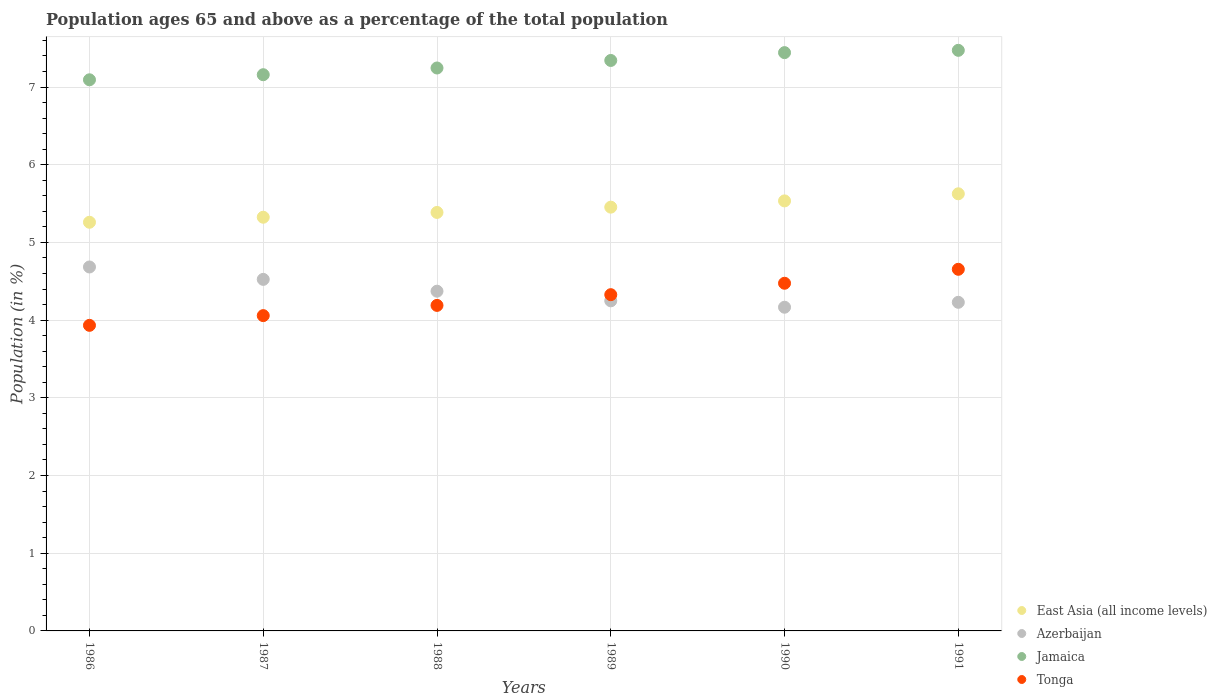Is the number of dotlines equal to the number of legend labels?
Provide a succinct answer. Yes. What is the percentage of the population ages 65 and above in Tonga in 1988?
Your response must be concise. 4.19. Across all years, what is the maximum percentage of the population ages 65 and above in Jamaica?
Your response must be concise. 7.47. Across all years, what is the minimum percentage of the population ages 65 and above in Azerbaijan?
Ensure brevity in your answer.  4.17. In which year was the percentage of the population ages 65 and above in Jamaica maximum?
Your answer should be compact. 1991. What is the total percentage of the population ages 65 and above in Tonga in the graph?
Make the answer very short. 25.64. What is the difference between the percentage of the population ages 65 and above in Azerbaijan in 1988 and that in 1989?
Provide a succinct answer. 0.12. What is the difference between the percentage of the population ages 65 and above in East Asia (all income levels) in 1991 and the percentage of the population ages 65 and above in Tonga in 1989?
Offer a terse response. 1.3. What is the average percentage of the population ages 65 and above in Tonga per year?
Your response must be concise. 4.27. In the year 1991, what is the difference between the percentage of the population ages 65 and above in Jamaica and percentage of the population ages 65 and above in East Asia (all income levels)?
Keep it short and to the point. 1.85. In how many years, is the percentage of the population ages 65 and above in Jamaica greater than 6.8?
Provide a succinct answer. 6. What is the ratio of the percentage of the population ages 65 and above in Jamaica in 1989 to that in 1990?
Offer a very short reply. 0.99. What is the difference between the highest and the second highest percentage of the population ages 65 and above in East Asia (all income levels)?
Make the answer very short. 0.09. What is the difference between the highest and the lowest percentage of the population ages 65 and above in Jamaica?
Your answer should be compact. 0.38. Is it the case that in every year, the sum of the percentage of the population ages 65 and above in Jamaica and percentage of the population ages 65 and above in East Asia (all income levels)  is greater than the sum of percentage of the population ages 65 and above in Azerbaijan and percentage of the population ages 65 and above in Tonga?
Your response must be concise. Yes. Does the percentage of the population ages 65 and above in East Asia (all income levels) monotonically increase over the years?
Give a very brief answer. Yes. How many legend labels are there?
Keep it short and to the point. 4. What is the title of the graph?
Provide a succinct answer. Population ages 65 and above as a percentage of the total population. Does "Rwanda" appear as one of the legend labels in the graph?
Ensure brevity in your answer.  No. What is the Population (in %) of East Asia (all income levels) in 1986?
Keep it short and to the point. 5.26. What is the Population (in %) of Azerbaijan in 1986?
Your answer should be compact. 4.68. What is the Population (in %) in Jamaica in 1986?
Make the answer very short. 7.09. What is the Population (in %) of Tonga in 1986?
Ensure brevity in your answer.  3.93. What is the Population (in %) in East Asia (all income levels) in 1987?
Make the answer very short. 5.32. What is the Population (in %) in Azerbaijan in 1987?
Ensure brevity in your answer.  4.52. What is the Population (in %) of Jamaica in 1987?
Offer a very short reply. 7.16. What is the Population (in %) of Tonga in 1987?
Provide a succinct answer. 4.06. What is the Population (in %) of East Asia (all income levels) in 1988?
Your response must be concise. 5.39. What is the Population (in %) in Azerbaijan in 1988?
Your answer should be compact. 4.37. What is the Population (in %) of Jamaica in 1988?
Provide a short and direct response. 7.25. What is the Population (in %) in Tonga in 1988?
Offer a terse response. 4.19. What is the Population (in %) of East Asia (all income levels) in 1989?
Your response must be concise. 5.45. What is the Population (in %) in Azerbaijan in 1989?
Your response must be concise. 4.25. What is the Population (in %) of Jamaica in 1989?
Your answer should be very brief. 7.34. What is the Population (in %) of Tonga in 1989?
Provide a short and direct response. 4.33. What is the Population (in %) of East Asia (all income levels) in 1990?
Offer a very short reply. 5.53. What is the Population (in %) of Azerbaijan in 1990?
Offer a very short reply. 4.17. What is the Population (in %) in Jamaica in 1990?
Your answer should be very brief. 7.44. What is the Population (in %) of Tonga in 1990?
Your answer should be very brief. 4.47. What is the Population (in %) in East Asia (all income levels) in 1991?
Provide a succinct answer. 5.63. What is the Population (in %) in Azerbaijan in 1991?
Provide a short and direct response. 4.23. What is the Population (in %) in Jamaica in 1991?
Ensure brevity in your answer.  7.47. What is the Population (in %) in Tonga in 1991?
Your answer should be very brief. 4.65. Across all years, what is the maximum Population (in %) of East Asia (all income levels)?
Ensure brevity in your answer.  5.63. Across all years, what is the maximum Population (in %) of Azerbaijan?
Keep it short and to the point. 4.68. Across all years, what is the maximum Population (in %) of Jamaica?
Provide a short and direct response. 7.47. Across all years, what is the maximum Population (in %) of Tonga?
Keep it short and to the point. 4.65. Across all years, what is the minimum Population (in %) in East Asia (all income levels)?
Your response must be concise. 5.26. Across all years, what is the minimum Population (in %) in Azerbaijan?
Provide a succinct answer. 4.17. Across all years, what is the minimum Population (in %) of Jamaica?
Provide a succinct answer. 7.09. Across all years, what is the minimum Population (in %) of Tonga?
Provide a succinct answer. 3.93. What is the total Population (in %) of East Asia (all income levels) in the graph?
Your response must be concise. 32.59. What is the total Population (in %) in Azerbaijan in the graph?
Offer a very short reply. 26.23. What is the total Population (in %) in Jamaica in the graph?
Your answer should be very brief. 43.76. What is the total Population (in %) of Tonga in the graph?
Provide a succinct answer. 25.64. What is the difference between the Population (in %) of East Asia (all income levels) in 1986 and that in 1987?
Keep it short and to the point. -0.06. What is the difference between the Population (in %) of Azerbaijan in 1986 and that in 1987?
Provide a short and direct response. 0.16. What is the difference between the Population (in %) of Jamaica in 1986 and that in 1987?
Provide a succinct answer. -0.07. What is the difference between the Population (in %) of Tonga in 1986 and that in 1987?
Provide a short and direct response. -0.13. What is the difference between the Population (in %) in East Asia (all income levels) in 1986 and that in 1988?
Offer a very short reply. -0.13. What is the difference between the Population (in %) of Azerbaijan in 1986 and that in 1988?
Ensure brevity in your answer.  0.31. What is the difference between the Population (in %) of Jamaica in 1986 and that in 1988?
Provide a short and direct response. -0.15. What is the difference between the Population (in %) in Tonga in 1986 and that in 1988?
Your response must be concise. -0.26. What is the difference between the Population (in %) in East Asia (all income levels) in 1986 and that in 1989?
Offer a terse response. -0.19. What is the difference between the Population (in %) of Azerbaijan in 1986 and that in 1989?
Give a very brief answer. 0.44. What is the difference between the Population (in %) of Jamaica in 1986 and that in 1989?
Provide a short and direct response. -0.25. What is the difference between the Population (in %) of Tonga in 1986 and that in 1989?
Your response must be concise. -0.39. What is the difference between the Population (in %) of East Asia (all income levels) in 1986 and that in 1990?
Make the answer very short. -0.27. What is the difference between the Population (in %) of Azerbaijan in 1986 and that in 1990?
Keep it short and to the point. 0.52. What is the difference between the Population (in %) of Jamaica in 1986 and that in 1990?
Provide a short and direct response. -0.35. What is the difference between the Population (in %) in Tonga in 1986 and that in 1990?
Your answer should be very brief. -0.54. What is the difference between the Population (in %) of East Asia (all income levels) in 1986 and that in 1991?
Your answer should be very brief. -0.37. What is the difference between the Population (in %) of Azerbaijan in 1986 and that in 1991?
Keep it short and to the point. 0.45. What is the difference between the Population (in %) in Jamaica in 1986 and that in 1991?
Ensure brevity in your answer.  -0.38. What is the difference between the Population (in %) of Tonga in 1986 and that in 1991?
Provide a succinct answer. -0.72. What is the difference between the Population (in %) in East Asia (all income levels) in 1987 and that in 1988?
Ensure brevity in your answer.  -0.06. What is the difference between the Population (in %) in Azerbaijan in 1987 and that in 1988?
Your answer should be compact. 0.15. What is the difference between the Population (in %) of Jamaica in 1987 and that in 1988?
Provide a succinct answer. -0.09. What is the difference between the Population (in %) of Tonga in 1987 and that in 1988?
Make the answer very short. -0.13. What is the difference between the Population (in %) of East Asia (all income levels) in 1987 and that in 1989?
Give a very brief answer. -0.13. What is the difference between the Population (in %) in Azerbaijan in 1987 and that in 1989?
Your response must be concise. 0.28. What is the difference between the Population (in %) in Jamaica in 1987 and that in 1989?
Provide a succinct answer. -0.18. What is the difference between the Population (in %) of Tonga in 1987 and that in 1989?
Make the answer very short. -0.27. What is the difference between the Population (in %) of East Asia (all income levels) in 1987 and that in 1990?
Your answer should be compact. -0.21. What is the difference between the Population (in %) of Azerbaijan in 1987 and that in 1990?
Your answer should be very brief. 0.36. What is the difference between the Population (in %) in Jamaica in 1987 and that in 1990?
Make the answer very short. -0.28. What is the difference between the Population (in %) in Tonga in 1987 and that in 1990?
Offer a terse response. -0.42. What is the difference between the Population (in %) of East Asia (all income levels) in 1987 and that in 1991?
Offer a very short reply. -0.3. What is the difference between the Population (in %) in Azerbaijan in 1987 and that in 1991?
Offer a very short reply. 0.3. What is the difference between the Population (in %) of Jamaica in 1987 and that in 1991?
Your answer should be very brief. -0.31. What is the difference between the Population (in %) in Tonga in 1987 and that in 1991?
Give a very brief answer. -0.6. What is the difference between the Population (in %) in East Asia (all income levels) in 1988 and that in 1989?
Provide a short and direct response. -0.07. What is the difference between the Population (in %) of Azerbaijan in 1988 and that in 1989?
Make the answer very short. 0.12. What is the difference between the Population (in %) in Jamaica in 1988 and that in 1989?
Your answer should be compact. -0.1. What is the difference between the Population (in %) of Tonga in 1988 and that in 1989?
Your answer should be very brief. -0.14. What is the difference between the Population (in %) in East Asia (all income levels) in 1988 and that in 1990?
Offer a terse response. -0.15. What is the difference between the Population (in %) in Azerbaijan in 1988 and that in 1990?
Your answer should be compact. 0.21. What is the difference between the Population (in %) of Jamaica in 1988 and that in 1990?
Your answer should be very brief. -0.2. What is the difference between the Population (in %) of Tonga in 1988 and that in 1990?
Give a very brief answer. -0.28. What is the difference between the Population (in %) in East Asia (all income levels) in 1988 and that in 1991?
Give a very brief answer. -0.24. What is the difference between the Population (in %) in Azerbaijan in 1988 and that in 1991?
Provide a short and direct response. 0.14. What is the difference between the Population (in %) in Jamaica in 1988 and that in 1991?
Ensure brevity in your answer.  -0.23. What is the difference between the Population (in %) of Tonga in 1988 and that in 1991?
Give a very brief answer. -0.46. What is the difference between the Population (in %) of East Asia (all income levels) in 1989 and that in 1990?
Your answer should be compact. -0.08. What is the difference between the Population (in %) in Azerbaijan in 1989 and that in 1990?
Ensure brevity in your answer.  0.08. What is the difference between the Population (in %) in Jamaica in 1989 and that in 1990?
Your response must be concise. -0.1. What is the difference between the Population (in %) of Tonga in 1989 and that in 1990?
Provide a short and direct response. -0.15. What is the difference between the Population (in %) of East Asia (all income levels) in 1989 and that in 1991?
Ensure brevity in your answer.  -0.17. What is the difference between the Population (in %) in Azerbaijan in 1989 and that in 1991?
Give a very brief answer. 0.02. What is the difference between the Population (in %) of Jamaica in 1989 and that in 1991?
Offer a terse response. -0.13. What is the difference between the Population (in %) of Tonga in 1989 and that in 1991?
Ensure brevity in your answer.  -0.33. What is the difference between the Population (in %) of East Asia (all income levels) in 1990 and that in 1991?
Ensure brevity in your answer.  -0.09. What is the difference between the Population (in %) of Azerbaijan in 1990 and that in 1991?
Make the answer very short. -0.06. What is the difference between the Population (in %) in Jamaica in 1990 and that in 1991?
Make the answer very short. -0.03. What is the difference between the Population (in %) of Tonga in 1990 and that in 1991?
Your answer should be compact. -0.18. What is the difference between the Population (in %) in East Asia (all income levels) in 1986 and the Population (in %) in Azerbaijan in 1987?
Your answer should be very brief. 0.74. What is the difference between the Population (in %) of East Asia (all income levels) in 1986 and the Population (in %) of Jamaica in 1987?
Give a very brief answer. -1.9. What is the difference between the Population (in %) in East Asia (all income levels) in 1986 and the Population (in %) in Tonga in 1987?
Keep it short and to the point. 1.2. What is the difference between the Population (in %) of Azerbaijan in 1986 and the Population (in %) of Jamaica in 1987?
Offer a very short reply. -2.47. What is the difference between the Population (in %) of Azerbaijan in 1986 and the Population (in %) of Tonga in 1987?
Keep it short and to the point. 0.63. What is the difference between the Population (in %) in Jamaica in 1986 and the Population (in %) in Tonga in 1987?
Make the answer very short. 3.04. What is the difference between the Population (in %) in East Asia (all income levels) in 1986 and the Population (in %) in Azerbaijan in 1988?
Your response must be concise. 0.89. What is the difference between the Population (in %) of East Asia (all income levels) in 1986 and the Population (in %) of Jamaica in 1988?
Provide a short and direct response. -1.99. What is the difference between the Population (in %) in East Asia (all income levels) in 1986 and the Population (in %) in Tonga in 1988?
Your answer should be compact. 1.07. What is the difference between the Population (in %) of Azerbaijan in 1986 and the Population (in %) of Jamaica in 1988?
Your response must be concise. -2.56. What is the difference between the Population (in %) in Azerbaijan in 1986 and the Population (in %) in Tonga in 1988?
Offer a very short reply. 0.49. What is the difference between the Population (in %) in Jamaica in 1986 and the Population (in %) in Tonga in 1988?
Provide a short and direct response. 2.9. What is the difference between the Population (in %) in East Asia (all income levels) in 1986 and the Population (in %) in Azerbaijan in 1989?
Provide a short and direct response. 1.01. What is the difference between the Population (in %) of East Asia (all income levels) in 1986 and the Population (in %) of Jamaica in 1989?
Keep it short and to the point. -2.08. What is the difference between the Population (in %) in East Asia (all income levels) in 1986 and the Population (in %) in Tonga in 1989?
Offer a very short reply. 0.93. What is the difference between the Population (in %) in Azerbaijan in 1986 and the Population (in %) in Jamaica in 1989?
Give a very brief answer. -2.66. What is the difference between the Population (in %) of Azerbaijan in 1986 and the Population (in %) of Tonga in 1989?
Your answer should be compact. 0.36. What is the difference between the Population (in %) of Jamaica in 1986 and the Population (in %) of Tonga in 1989?
Give a very brief answer. 2.77. What is the difference between the Population (in %) in East Asia (all income levels) in 1986 and the Population (in %) in Azerbaijan in 1990?
Your answer should be compact. 1.09. What is the difference between the Population (in %) in East Asia (all income levels) in 1986 and the Population (in %) in Jamaica in 1990?
Provide a succinct answer. -2.18. What is the difference between the Population (in %) of East Asia (all income levels) in 1986 and the Population (in %) of Tonga in 1990?
Ensure brevity in your answer.  0.79. What is the difference between the Population (in %) in Azerbaijan in 1986 and the Population (in %) in Jamaica in 1990?
Your response must be concise. -2.76. What is the difference between the Population (in %) of Azerbaijan in 1986 and the Population (in %) of Tonga in 1990?
Your answer should be compact. 0.21. What is the difference between the Population (in %) of Jamaica in 1986 and the Population (in %) of Tonga in 1990?
Offer a terse response. 2.62. What is the difference between the Population (in %) of East Asia (all income levels) in 1986 and the Population (in %) of Azerbaijan in 1991?
Make the answer very short. 1.03. What is the difference between the Population (in %) of East Asia (all income levels) in 1986 and the Population (in %) of Jamaica in 1991?
Provide a succinct answer. -2.21. What is the difference between the Population (in %) of East Asia (all income levels) in 1986 and the Population (in %) of Tonga in 1991?
Give a very brief answer. 0.61. What is the difference between the Population (in %) of Azerbaijan in 1986 and the Population (in %) of Jamaica in 1991?
Your response must be concise. -2.79. What is the difference between the Population (in %) of Azerbaijan in 1986 and the Population (in %) of Tonga in 1991?
Provide a short and direct response. 0.03. What is the difference between the Population (in %) in Jamaica in 1986 and the Population (in %) in Tonga in 1991?
Your answer should be very brief. 2.44. What is the difference between the Population (in %) in East Asia (all income levels) in 1987 and the Population (in %) in Azerbaijan in 1988?
Your answer should be very brief. 0.95. What is the difference between the Population (in %) of East Asia (all income levels) in 1987 and the Population (in %) of Jamaica in 1988?
Make the answer very short. -1.92. What is the difference between the Population (in %) of East Asia (all income levels) in 1987 and the Population (in %) of Tonga in 1988?
Your answer should be very brief. 1.13. What is the difference between the Population (in %) of Azerbaijan in 1987 and the Population (in %) of Jamaica in 1988?
Offer a terse response. -2.72. What is the difference between the Population (in %) in Azerbaijan in 1987 and the Population (in %) in Tonga in 1988?
Provide a succinct answer. 0.33. What is the difference between the Population (in %) of Jamaica in 1987 and the Population (in %) of Tonga in 1988?
Your answer should be very brief. 2.97. What is the difference between the Population (in %) in East Asia (all income levels) in 1987 and the Population (in %) in Azerbaijan in 1989?
Your answer should be very brief. 1.08. What is the difference between the Population (in %) of East Asia (all income levels) in 1987 and the Population (in %) of Jamaica in 1989?
Your answer should be very brief. -2.02. What is the difference between the Population (in %) in East Asia (all income levels) in 1987 and the Population (in %) in Tonga in 1989?
Give a very brief answer. 1. What is the difference between the Population (in %) in Azerbaijan in 1987 and the Population (in %) in Jamaica in 1989?
Your response must be concise. -2.82. What is the difference between the Population (in %) in Azerbaijan in 1987 and the Population (in %) in Tonga in 1989?
Provide a succinct answer. 0.2. What is the difference between the Population (in %) of Jamaica in 1987 and the Population (in %) of Tonga in 1989?
Keep it short and to the point. 2.83. What is the difference between the Population (in %) in East Asia (all income levels) in 1987 and the Population (in %) in Azerbaijan in 1990?
Keep it short and to the point. 1.16. What is the difference between the Population (in %) of East Asia (all income levels) in 1987 and the Population (in %) of Jamaica in 1990?
Your answer should be very brief. -2.12. What is the difference between the Population (in %) in East Asia (all income levels) in 1987 and the Population (in %) in Tonga in 1990?
Your response must be concise. 0.85. What is the difference between the Population (in %) in Azerbaijan in 1987 and the Population (in %) in Jamaica in 1990?
Offer a very short reply. -2.92. What is the difference between the Population (in %) in Azerbaijan in 1987 and the Population (in %) in Tonga in 1990?
Your answer should be compact. 0.05. What is the difference between the Population (in %) in Jamaica in 1987 and the Population (in %) in Tonga in 1990?
Offer a terse response. 2.68. What is the difference between the Population (in %) of East Asia (all income levels) in 1987 and the Population (in %) of Azerbaijan in 1991?
Provide a succinct answer. 1.1. What is the difference between the Population (in %) in East Asia (all income levels) in 1987 and the Population (in %) in Jamaica in 1991?
Your answer should be very brief. -2.15. What is the difference between the Population (in %) of East Asia (all income levels) in 1987 and the Population (in %) of Tonga in 1991?
Your answer should be compact. 0.67. What is the difference between the Population (in %) of Azerbaijan in 1987 and the Population (in %) of Jamaica in 1991?
Your answer should be very brief. -2.95. What is the difference between the Population (in %) of Azerbaijan in 1987 and the Population (in %) of Tonga in 1991?
Provide a short and direct response. -0.13. What is the difference between the Population (in %) of Jamaica in 1987 and the Population (in %) of Tonga in 1991?
Offer a terse response. 2.5. What is the difference between the Population (in %) in East Asia (all income levels) in 1988 and the Population (in %) in Azerbaijan in 1989?
Keep it short and to the point. 1.14. What is the difference between the Population (in %) of East Asia (all income levels) in 1988 and the Population (in %) of Jamaica in 1989?
Offer a terse response. -1.96. What is the difference between the Population (in %) in East Asia (all income levels) in 1988 and the Population (in %) in Tonga in 1989?
Make the answer very short. 1.06. What is the difference between the Population (in %) of Azerbaijan in 1988 and the Population (in %) of Jamaica in 1989?
Make the answer very short. -2.97. What is the difference between the Population (in %) of Azerbaijan in 1988 and the Population (in %) of Tonga in 1989?
Keep it short and to the point. 0.04. What is the difference between the Population (in %) of Jamaica in 1988 and the Population (in %) of Tonga in 1989?
Give a very brief answer. 2.92. What is the difference between the Population (in %) in East Asia (all income levels) in 1988 and the Population (in %) in Azerbaijan in 1990?
Provide a short and direct response. 1.22. What is the difference between the Population (in %) in East Asia (all income levels) in 1988 and the Population (in %) in Jamaica in 1990?
Give a very brief answer. -2.06. What is the difference between the Population (in %) in East Asia (all income levels) in 1988 and the Population (in %) in Tonga in 1990?
Your answer should be very brief. 0.91. What is the difference between the Population (in %) of Azerbaijan in 1988 and the Population (in %) of Jamaica in 1990?
Ensure brevity in your answer.  -3.07. What is the difference between the Population (in %) in Azerbaijan in 1988 and the Population (in %) in Tonga in 1990?
Provide a succinct answer. -0.1. What is the difference between the Population (in %) in Jamaica in 1988 and the Population (in %) in Tonga in 1990?
Your answer should be compact. 2.77. What is the difference between the Population (in %) in East Asia (all income levels) in 1988 and the Population (in %) in Azerbaijan in 1991?
Your answer should be very brief. 1.16. What is the difference between the Population (in %) in East Asia (all income levels) in 1988 and the Population (in %) in Jamaica in 1991?
Offer a terse response. -2.09. What is the difference between the Population (in %) of East Asia (all income levels) in 1988 and the Population (in %) of Tonga in 1991?
Offer a very short reply. 0.73. What is the difference between the Population (in %) of Azerbaijan in 1988 and the Population (in %) of Jamaica in 1991?
Give a very brief answer. -3.1. What is the difference between the Population (in %) of Azerbaijan in 1988 and the Population (in %) of Tonga in 1991?
Provide a succinct answer. -0.28. What is the difference between the Population (in %) in Jamaica in 1988 and the Population (in %) in Tonga in 1991?
Make the answer very short. 2.59. What is the difference between the Population (in %) of East Asia (all income levels) in 1989 and the Population (in %) of Azerbaijan in 1990?
Give a very brief answer. 1.29. What is the difference between the Population (in %) of East Asia (all income levels) in 1989 and the Population (in %) of Jamaica in 1990?
Provide a short and direct response. -1.99. What is the difference between the Population (in %) in East Asia (all income levels) in 1989 and the Population (in %) in Tonga in 1990?
Your answer should be very brief. 0.98. What is the difference between the Population (in %) in Azerbaijan in 1989 and the Population (in %) in Jamaica in 1990?
Your answer should be very brief. -3.19. What is the difference between the Population (in %) of Azerbaijan in 1989 and the Population (in %) of Tonga in 1990?
Your response must be concise. -0.23. What is the difference between the Population (in %) in Jamaica in 1989 and the Population (in %) in Tonga in 1990?
Your answer should be compact. 2.87. What is the difference between the Population (in %) of East Asia (all income levels) in 1989 and the Population (in %) of Azerbaijan in 1991?
Your answer should be very brief. 1.22. What is the difference between the Population (in %) in East Asia (all income levels) in 1989 and the Population (in %) in Jamaica in 1991?
Provide a short and direct response. -2.02. What is the difference between the Population (in %) of East Asia (all income levels) in 1989 and the Population (in %) of Tonga in 1991?
Ensure brevity in your answer.  0.8. What is the difference between the Population (in %) in Azerbaijan in 1989 and the Population (in %) in Jamaica in 1991?
Make the answer very short. -3.22. What is the difference between the Population (in %) in Azerbaijan in 1989 and the Population (in %) in Tonga in 1991?
Ensure brevity in your answer.  -0.41. What is the difference between the Population (in %) in Jamaica in 1989 and the Population (in %) in Tonga in 1991?
Keep it short and to the point. 2.69. What is the difference between the Population (in %) in East Asia (all income levels) in 1990 and the Population (in %) in Azerbaijan in 1991?
Provide a short and direct response. 1.31. What is the difference between the Population (in %) of East Asia (all income levels) in 1990 and the Population (in %) of Jamaica in 1991?
Provide a short and direct response. -1.94. What is the difference between the Population (in %) of East Asia (all income levels) in 1990 and the Population (in %) of Tonga in 1991?
Ensure brevity in your answer.  0.88. What is the difference between the Population (in %) in Azerbaijan in 1990 and the Population (in %) in Jamaica in 1991?
Give a very brief answer. -3.31. What is the difference between the Population (in %) of Azerbaijan in 1990 and the Population (in %) of Tonga in 1991?
Keep it short and to the point. -0.49. What is the difference between the Population (in %) in Jamaica in 1990 and the Population (in %) in Tonga in 1991?
Your answer should be very brief. 2.79. What is the average Population (in %) in East Asia (all income levels) per year?
Your response must be concise. 5.43. What is the average Population (in %) in Azerbaijan per year?
Your response must be concise. 4.37. What is the average Population (in %) in Jamaica per year?
Ensure brevity in your answer.  7.29. What is the average Population (in %) of Tonga per year?
Provide a short and direct response. 4.27. In the year 1986, what is the difference between the Population (in %) of East Asia (all income levels) and Population (in %) of Azerbaijan?
Your answer should be very brief. 0.58. In the year 1986, what is the difference between the Population (in %) of East Asia (all income levels) and Population (in %) of Jamaica?
Your response must be concise. -1.83. In the year 1986, what is the difference between the Population (in %) of East Asia (all income levels) and Population (in %) of Tonga?
Offer a terse response. 1.33. In the year 1986, what is the difference between the Population (in %) of Azerbaijan and Population (in %) of Jamaica?
Your answer should be compact. -2.41. In the year 1986, what is the difference between the Population (in %) in Azerbaijan and Population (in %) in Tonga?
Provide a succinct answer. 0.75. In the year 1986, what is the difference between the Population (in %) in Jamaica and Population (in %) in Tonga?
Keep it short and to the point. 3.16. In the year 1987, what is the difference between the Population (in %) of East Asia (all income levels) and Population (in %) of Jamaica?
Offer a very short reply. -1.83. In the year 1987, what is the difference between the Population (in %) in East Asia (all income levels) and Population (in %) in Tonga?
Keep it short and to the point. 1.27. In the year 1987, what is the difference between the Population (in %) of Azerbaijan and Population (in %) of Jamaica?
Keep it short and to the point. -2.63. In the year 1987, what is the difference between the Population (in %) of Azerbaijan and Population (in %) of Tonga?
Provide a succinct answer. 0.47. In the year 1987, what is the difference between the Population (in %) in Jamaica and Population (in %) in Tonga?
Offer a very short reply. 3.1. In the year 1988, what is the difference between the Population (in %) in East Asia (all income levels) and Population (in %) in Azerbaijan?
Ensure brevity in your answer.  1.01. In the year 1988, what is the difference between the Population (in %) in East Asia (all income levels) and Population (in %) in Jamaica?
Your response must be concise. -1.86. In the year 1988, what is the difference between the Population (in %) in East Asia (all income levels) and Population (in %) in Tonga?
Provide a succinct answer. 1.2. In the year 1988, what is the difference between the Population (in %) of Azerbaijan and Population (in %) of Jamaica?
Provide a short and direct response. -2.87. In the year 1988, what is the difference between the Population (in %) of Azerbaijan and Population (in %) of Tonga?
Offer a terse response. 0.18. In the year 1988, what is the difference between the Population (in %) in Jamaica and Population (in %) in Tonga?
Provide a succinct answer. 3.06. In the year 1989, what is the difference between the Population (in %) in East Asia (all income levels) and Population (in %) in Azerbaijan?
Your response must be concise. 1.21. In the year 1989, what is the difference between the Population (in %) in East Asia (all income levels) and Population (in %) in Jamaica?
Your answer should be very brief. -1.89. In the year 1989, what is the difference between the Population (in %) in East Asia (all income levels) and Population (in %) in Tonga?
Offer a very short reply. 1.13. In the year 1989, what is the difference between the Population (in %) in Azerbaijan and Population (in %) in Jamaica?
Ensure brevity in your answer.  -3.09. In the year 1989, what is the difference between the Population (in %) in Azerbaijan and Population (in %) in Tonga?
Offer a terse response. -0.08. In the year 1989, what is the difference between the Population (in %) in Jamaica and Population (in %) in Tonga?
Ensure brevity in your answer.  3.01. In the year 1990, what is the difference between the Population (in %) of East Asia (all income levels) and Population (in %) of Azerbaijan?
Give a very brief answer. 1.37. In the year 1990, what is the difference between the Population (in %) in East Asia (all income levels) and Population (in %) in Jamaica?
Provide a short and direct response. -1.91. In the year 1990, what is the difference between the Population (in %) of East Asia (all income levels) and Population (in %) of Tonga?
Provide a short and direct response. 1.06. In the year 1990, what is the difference between the Population (in %) in Azerbaijan and Population (in %) in Jamaica?
Keep it short and to the point. -3.28. In the year 1990, what is the difference between the Population (in %) of Azerbaijan and Population (in %) of Tonga?
Offer a terse response. -0.31. In the year 1990, what is the difference between the Population (in %) in Jamaica and Population (in %) in Tonga?
Offer a terse response. 2.97. In the year 1991, what is the difference between the Population (in %) in East Asia (all income levels) and Population (in %) in Azerbaijan?
Offer a very short reply. 1.4. In the year 1991, what is the difference between the Population (in %) in East Asia (all income levels) and Population (in %) in Jamaica?
Keep it short and to the point. -1.85. In the year 1991, what is the difference between the Population (in %) of East Asia (all income levels) and Population (in %) of Tonga?
Your answer should be compact. 0.97. In the year 1991, what is the difference between the Population (in %) of Azerbaijan and Population (in %) of Jamaica?
Ensure brevity in your answer.  -3.24. In the year 1991, what is the difference between the Population (in %) of Azerbaijan and Population (in %) of Tonga?
Your answer should be very brief. -0.42. In the year 1991, what is the difference between the Population (in %) of Jamaica and Population (in %) of Tonga?
Make the answer very short. 2.82. What is the ratio of the Population (in %) in Azerbaijan in 1986 to that in 1987?
Offer a very short reply. 1.04. What is the ratio of the Population (in %) of Jamaica in 1986 to that in 1987?
Offer a very short reply. 0.99. What is the ratio of the Population (in %) of Tonga in 1986 to that in 1987?
Offer a terse response. 0.97. What is the ratio of the Population (in %) of East Asia (all income levels) in 1986 to that in 1988?
Give a very brief answer. 0.98. What is the ratio of the Population (in %) of Azerbaijan in 1986 to that in 1988?
Your response must be concise. 1.07. What is the ratio of the Population (in %) in Jamaica in 1986 to that in 1988?
Keep it short and to the point. 0.98. What is the ratio of the Population (in %) of Tonga in 1986 to that in 1988?
Provide a short and direct response. 0.94. What is the ratio of the Population (in %) in East Asia (all income levels) in 1986 to that in 1989?
Offer a terse response. 0.96. What is the ratio of the Population (in %) in Azerbaijan in 1986 to that in 1989?
Your answer should be compact. 1.1. What is the ratio of the Population (in %) of Jamaica in 1986 to that in 1989?
Offer a terse response. 0.97. What is the ratio of the Population (in %) in Tonga in 1986 to that in 1989?
Provide a succinct answer. 0.91. What is the ratio of the Population (in %) of East Asia (all income levels) in 1986 to that in 1990?
Your answer should be very brief. 0.95. What is the ratio of the Population (in %) of Azerbaijan in 1986 to that in 1990?
Make the answer very short. 1.12. What is the ratio of the Population (in %) in Jamaica in 1986 to that in 1990?
Your answer should be very brief. 0.95. What is the ratio of the Population (in %) of Tonga in 1986 to that in 1990?
Provide a short and direct response. 0.88. What is the ratio of the Population (in %) in East Asia (all income levels) in 1986 to that in 1991?
Offer a very short reply. 0.93. What is the ratio of the Population (in %) of Azerbaijan in 1986 to that in 1991?
Make the answer very short. 1.11. What is the ratio of the Population (in %) in Jamaica in 1986 to that in 1991?
Offer a terse response. 0.95. What is the ratio of the Population (in %) of Tonga in 1986 to that in 1991?
Provide a succinct answer. 0.84. What is the ratio of the Population (in %) of East Asia (all income levels) in 1987 to that in 1988?
Offer a terse response. 0.99. What is the ratio of the Population (in %) of Azerbaijan in 1987 to that in 1988?
Provide a short and direct response. 1.03. What is the ratio of the Population (in %) of Jamaica in 1987 to that in 1988?
Provide a short and direct response. 0.99. What is the ratio of the Population (in %) in Tonga in 1987 to that in 1988?
Your response must be concise. 0.97. What is the ratio of the Population (in %) of East Asia (all income levels) in 1987 to that in 1989?
Give a very brief answer. 0.98. What is the ratio of the Population (in %) of Azerbaijan in 1987 to that in 1989?
Ensure brevity in your answer.  1.06. What is the ratio of the Population (in %) of Jamaica in 1987 to that in 1989?
Provide a short and direct response. 0.97. What is the ratio of the Population (in %) in Tonga in 1987 to that in 1989?
Your answer should be compact. 0.94. What is the ratio of the Population (in %) of East Asia (all income levels) in 1987 to that in 1990?
Provide a succinct answer. 0.96. What is the ratio of the Population (in %) in Azerbaijan in 1987 to that in 1990?
Provide a succinct answer. 1.09. What is the ratio of the Population (in %) of Jamaica in 1987 to that in 1990?
Offer a very short reply. 0.96. What is the ratio of the Population (in %) of Tonga in 1987 to that in 1990?
Provide a succinct answer. 0.91. What is the ratio of the Population (in %) of East Asia (all income levels) in 1987 to that in 1991?
Provide a succinct answer. 0.95. What is the ratio of the Population (in %) in Azerbaijan in 1987 to that in 1991?
Your answer should be compact. 1.07. What is the ratio of the Population (in %) in Jamaica in 1987 to that in 1991?
Your response must be concise. 0.96. What is the ratio of the Population (in %) in Tonga in 1987 to that in 1991?
Provide a short and direct response. 0.87. What is the ratio of the Population (in %) of East Asia (all income levels) in 1988 to that in 1989?
Provide a short and direct response. 0.99. What is the ratio of the Population (in %) of Azerbaijan in 1988 to that in 1989?
Ensure brevity in your answer.  1.03. What is the ratio of the Population (in %) in Jamaica in 1988 to that in 1989?
Offer a terse response. 0.99. What is the ratio of the Population (in %) in Tonga in 1988 to that in 1989?
Make the answer very short. 0.97. What is the ratio of the Population (in %) in East Asia (all income levels) in 1988 to that in 1990?
Keep it short and to the point. 0.97. What is the ratio of the Population (in %) in Azerbaijan in 1988 to that in 1990?
Give a very brief answer. 1.05. What is the ratio of the Population (in %) of Jamaica in 1988 to that in 1990?
Ensure brevity in your answer.  0.97. What is the ratio of the Population (in %) of Tonga in 1988 to that in 1990?
Keep it short and to the point. 0.94. What is the ratio of the Population (in %) of East Asia (all income levels) in 1988 to that in 1991?
Your response must be concise. 0.96. What is the ratio of the Population (in %) of Azerbaijan in 1988 to that in 1991?
Provide a short and direct response. 1.03. What is the ratio of the Population (in %) of Jamaica in 1988 to that in 1991?
Keep it short and to the point. 0.97. What is the ratio of the Population (in %) in Tonga in 1988 to that in 1991?
Keep it short and to the point. 0.9. What is the ratio of the Population (in %) of East Asia (all income levels) in 1989 to that in 1990?
Make the answer very short. 0.99. What is the ratio of the Population (in %) in Azerbaijan in 1989 to that in 1990?
Ensure brevity in your answer.  1.02. What is the ratio of the Population (in %) in Jamaica in 1989 to that in 1990?
Offer a very short reply. 0.99. What is the ratio of the Population (in %) of Tonga in 1989 to that in 1990?
Give a very brief answer. 0.97. What is the ratio of the Population (in %) in East Asia (all income levels) in 1989 to that in 1991?
Give a very brief answer. 0.97. What is the ratio of the Population (in %) in Jamaica in 1989 to that in 1991?
Make the answer very short. 0.98. What is the ratio of the Population (in %) in Tonga in 1989 to that in 1991?
Provide a succinct answer. 0.93. What is the ratio of the Population (in %) in East Asia (all income levels) in 1990 to that in 1991?
Provide a short and direct response. 0.98. What is the ratio of the Population (in %) in Azerbaijan in 1990 to that in 1991?
Make the answer very short. 0.98. What is the ratio of the Population (in %) of Jamaica in 1990 to that in 1991?
Ensure brevity in your answer.  1. What is the ratio of the Population (in %) of Tonga in 1990 to that in 1991?
Your response must be concise. 0.96. What is the difference between the highest and the second highest Population (in %) in East Asia (all income levels)?
Your response must be concise. 0.09. What is the difference between the highest and the second highest Population (in %) in Azerbaijan?
Offer a very short reply. 0.16. What is the difference between the highest and the second highest Population (in %) in Jamaica?
Ensure brevity in your answer.  0.03. What is the difference between the highest and the second highest Population (in %) in Tonga?
Your response must be concise. 0.18. What is the difference between the highest and the lowest Population (in %) in East Asia (all income levels)?
Offer a terse response. 0.37. What is the difference between the highest and the lowest Population (in %) in Azerbaijan?
Make the answer very short. 0.52. What is the difference between the highest and the lowest Population (in %) of Jamaica?
Provide a succinct answer. 0.38. What is the difference between the highest and the lowest Population (in %) in Tonga?
Make the answer very short. 0.72. 